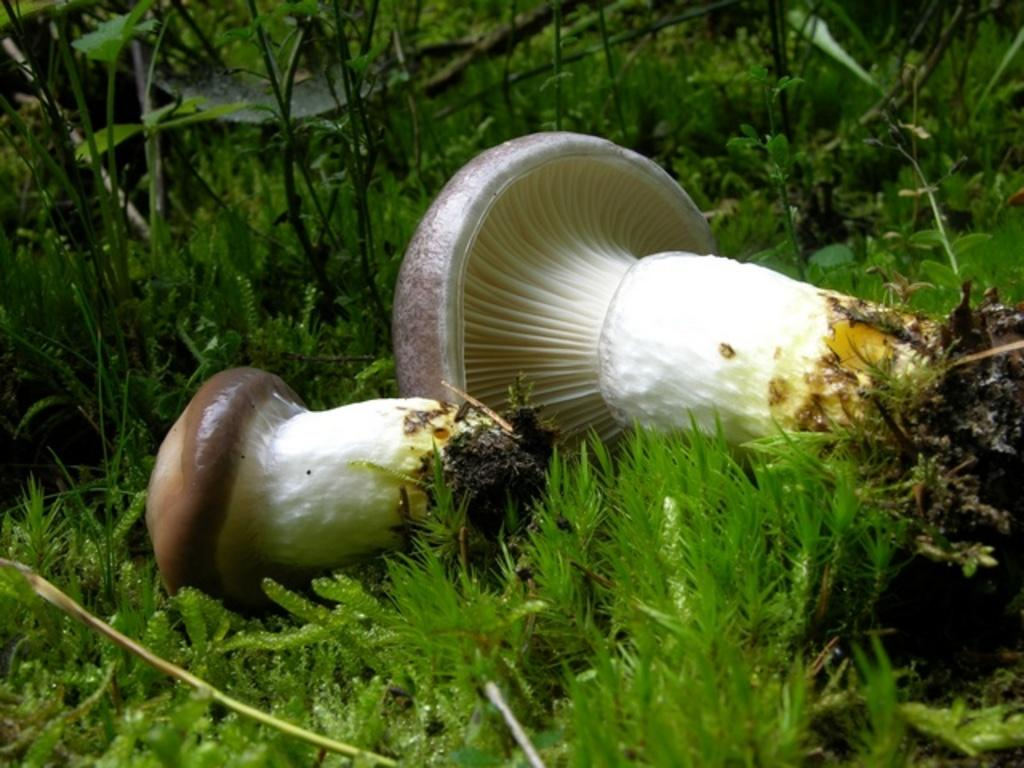What objects are present in the image? There are two white mushrooms in the image. Where are the mushrooms located? The mushrooms are located in the middle of the image. What else can be seen in the image besides the mushrooms? There are plants visible in the image, at the back side. What type of brush is the manager using to paint the airplane in the image? There is no brush, manager, or airplane present in the image; it only features two white mushrooms and some plants. 